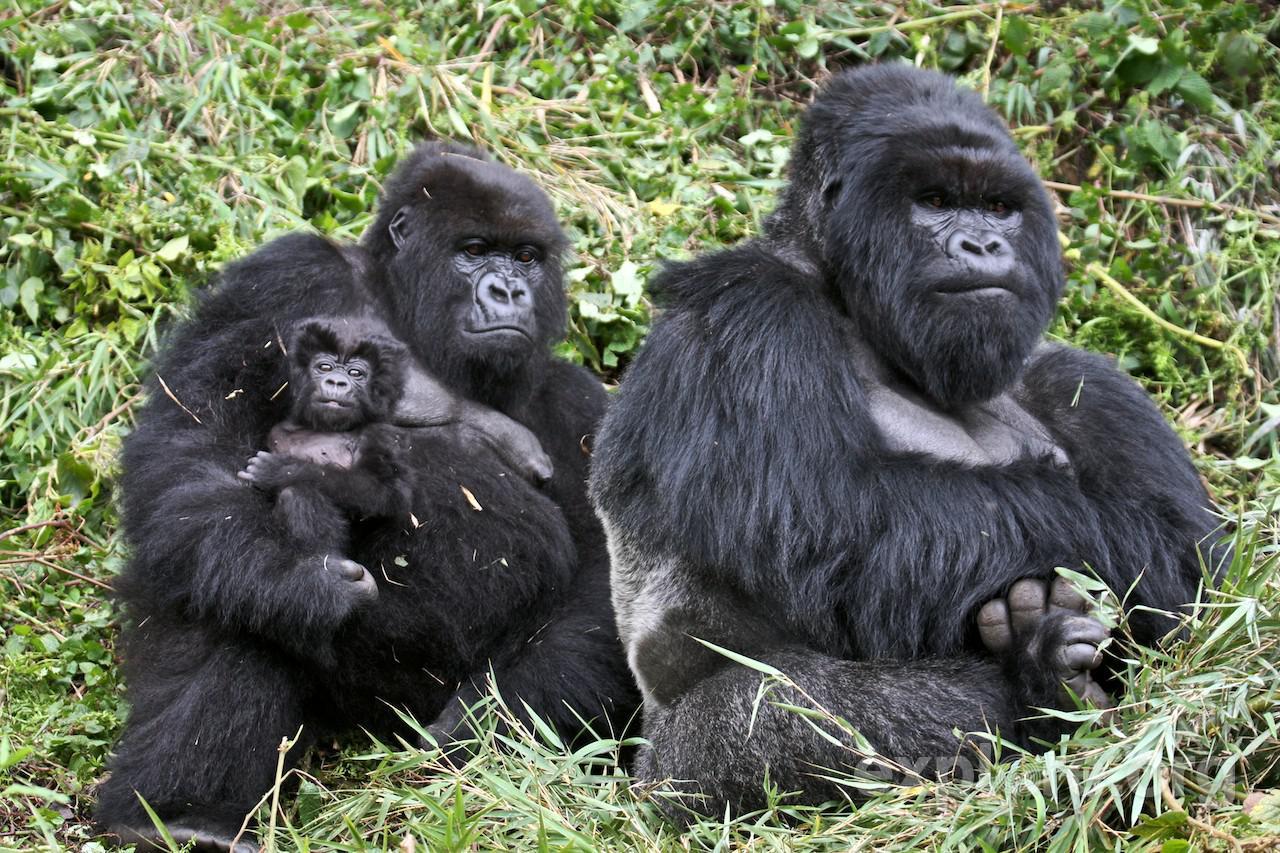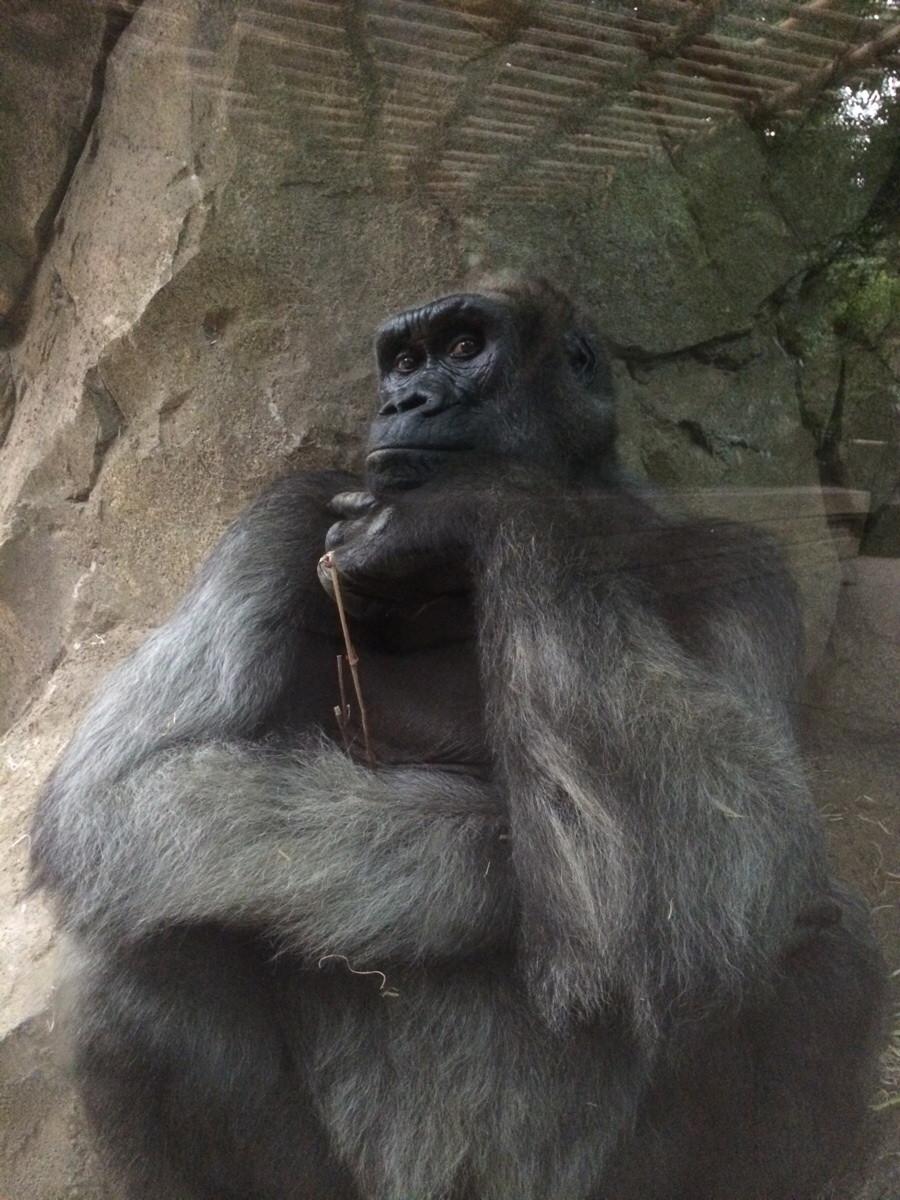The first image is the image on the left, the second image is the image on the right. For the images shown, is this caption "One of the gorillas is touching its face with its left hand." true? Answer yes or no. Yes. 